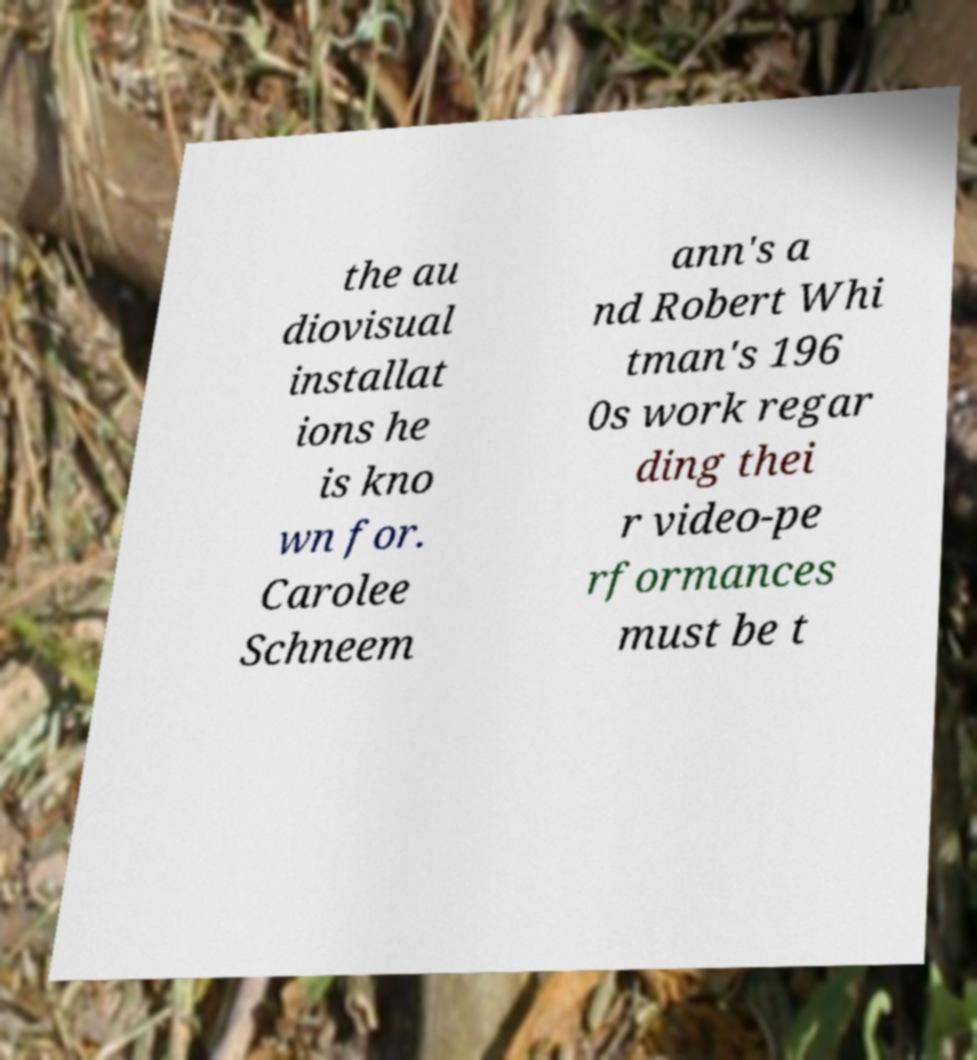Could you assist in decoding the text presented in this image and type it out clearly? the au diovisual installat ions he is kno wn for. Carolee Schneem ann's a nd Robert Whi tman's 196 0s work regar ding thei r video-pe rformances must be t 